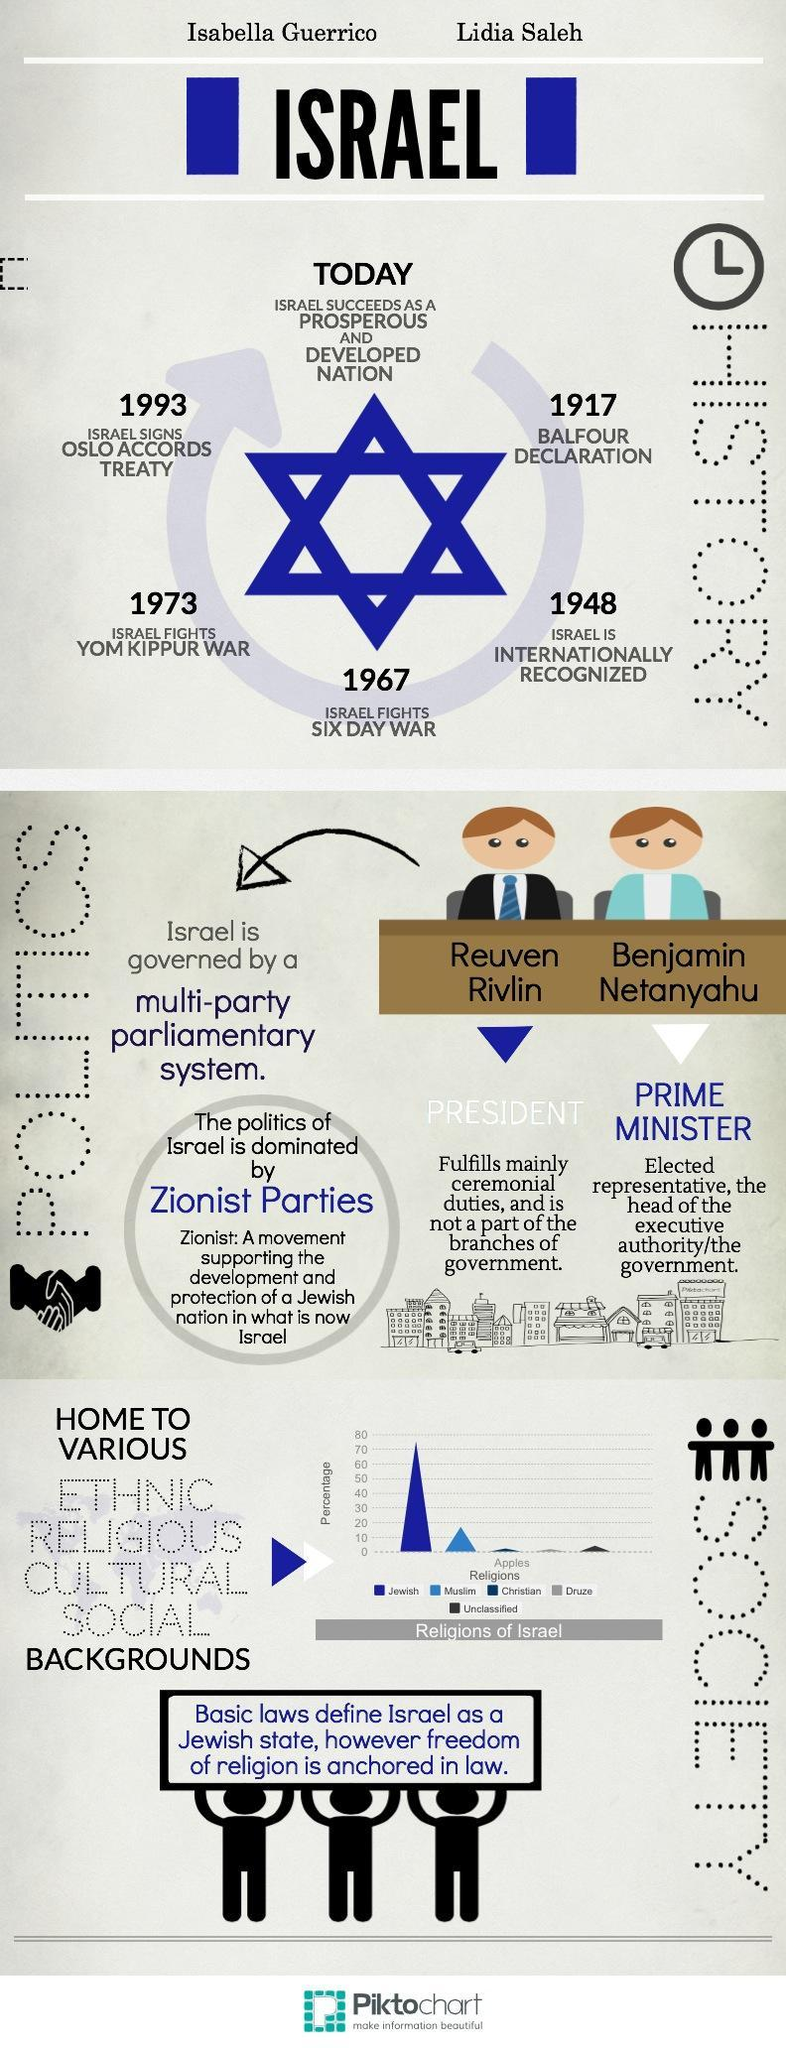Who is the elected representative and head of government?
Answer the question with a short phrase. Prime Minister Who is the prime minister of Israel? Benjamin Netanyahu When was Israel internationally recognized? 1948 To which religion does the second highest percent of people belong? Muslim Who fulfills mainly ceremonial duties? President In which year did Israel sign Oslo Accords treaty? 1993 In which year was the Yom Kippur war? 1973 When was the Balfour declaration made? 1917 Who is the President of Israel? Reuven Rivlin 